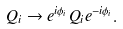<formula> <loc_0><loc_0><loc_500><loc_500>Q _ { i } \to e ^ { i \phi _ { i } } Q _ { i } e ^ { - i \phi _ { i } } .</formula> 